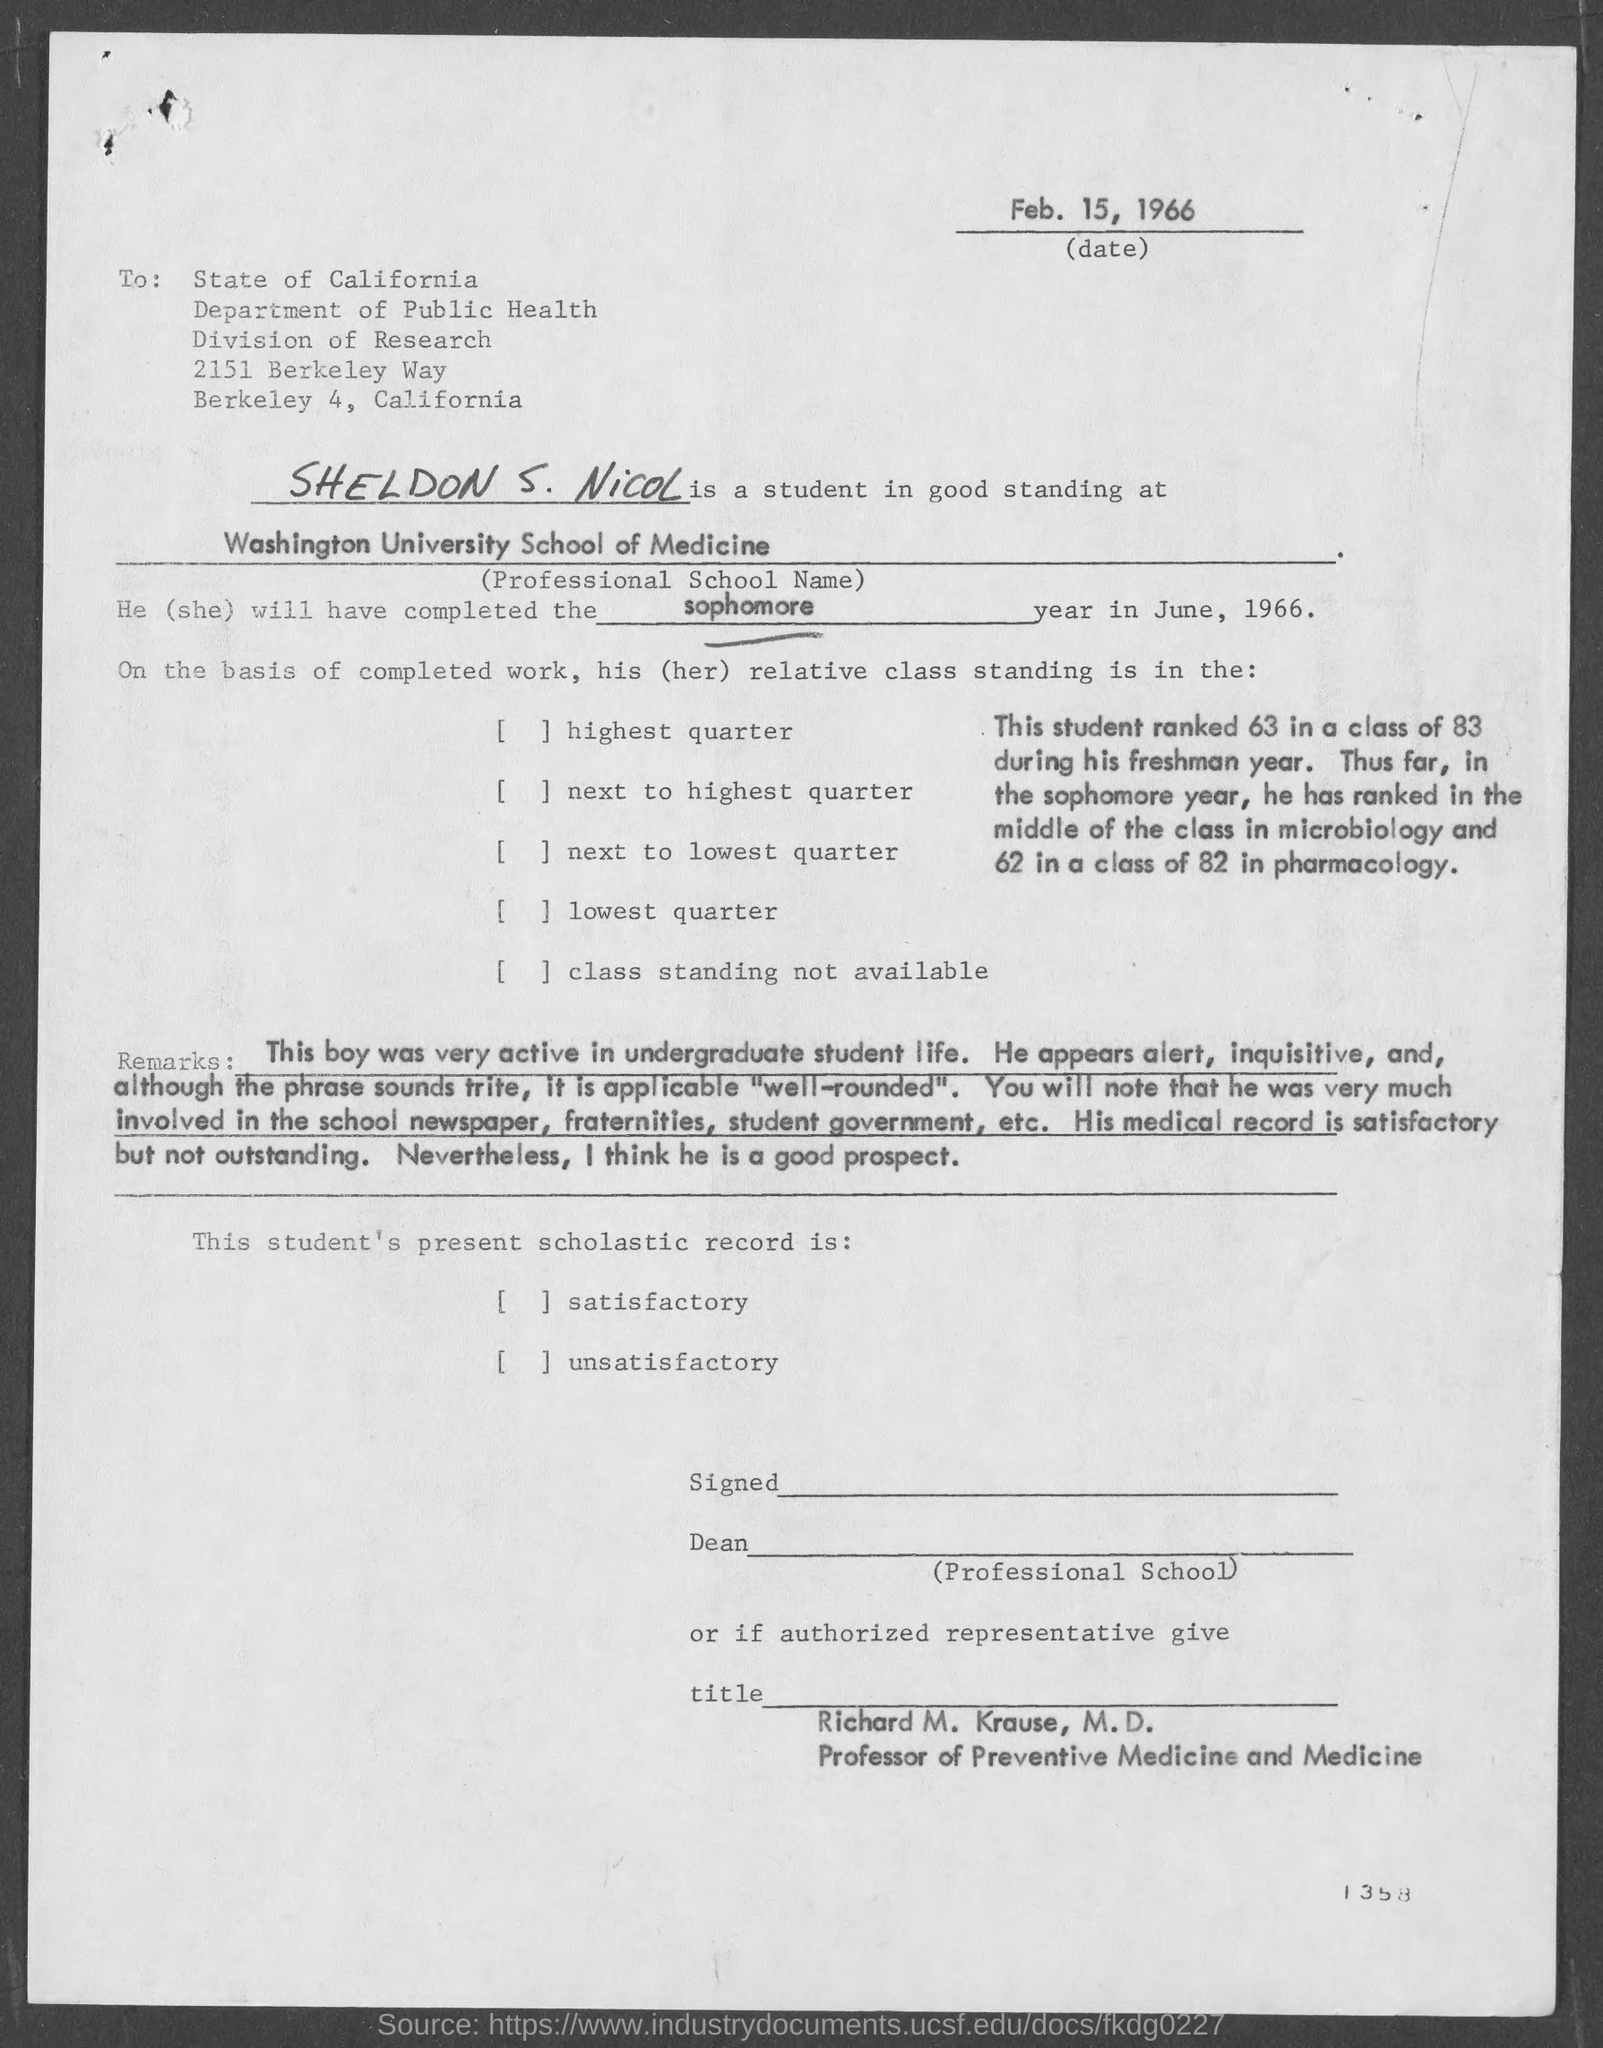When is the document dated?
Provide a short and direct response. Feb. 15, 1966. To which state is the letter addressed?
Offer a terse response. State of California. Which department is involved?
Give a very brief answer. Department of Public Health. What is the name of the student?
Provide a short and direct response. SHELDON S. NICOL. What is the professional school of medicine?
Your answer should be compact. Washington University School of Medicine. Which year will Sheldon complete in June, 1966?
Offer a very short reply. Sophomore. When will the student complete his sophomore year?
Offer a very short reply. June, 1966. 